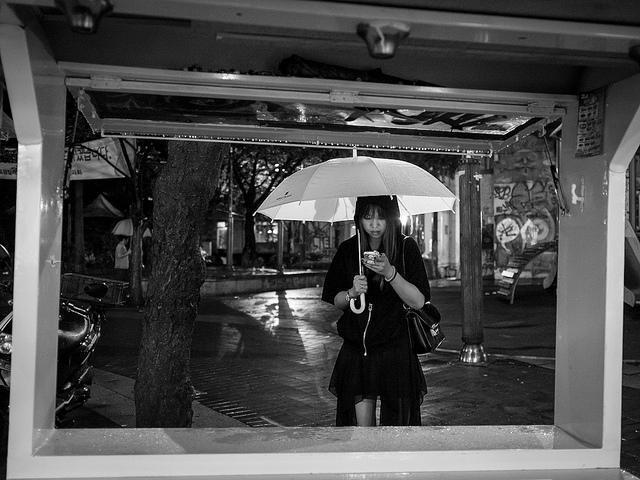How many items is the girl carrying?
Give a very brief answer. 3. 